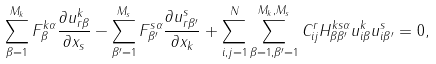<formula> <loc_0><loc_0><loc_500><loc_500>\sum _ { \beta = 1 } ^ { M _ { k } } F ^ { k \alpha } _ { \beta } \frac { \partial u _ { r \beta } ^ { k } } { \partial x _ { s } } - \sum _ { \beta ^ { \prime } = 1 } ^ { M _ { s } } F ^ { s \alpha } _ { \beta ^ { \prime } } \frac { \partial u _ { r \beta ^ { \prime } } ^ { s } } { \partial x _ { k } } + \sum _ { i , j = 1 } ^ { N } \sum _ { \beta = 1 , \beta ^ { \prime } = 1 } ^ { M _ { k } , M _ { s } } C _ { i j } ^ { r } H ^ { k s \alpha } _ { \beta \beta ^ { \prime } } u ^ { k } _ { i \beta } u ^ { s } _ { i \beta ^ { \prime } } = 0 ,</formula> 